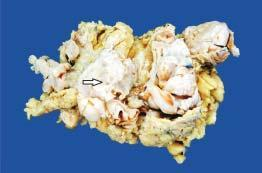does simple mastectomy specimen show replacement of almost whole breast with a large circumscribed, greywhite, firm, nodular mass having slit-like, compressed cystic areas and areas of haemorrhage?
Answer the question using a single word or phrase. Yes 